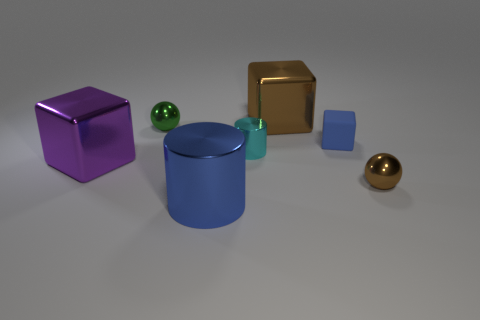There is a tiny green shiny ball; what number of small blue matte blocks are behind it?
Keep it short and to the point. 0. Is the number of green spheres greater than the number of big red rubber cylinders?
Provide a succinct answer. Yes. There is a metal cylinder that is the same color as the small block; what is its size?
Your response must be concise. Large. There is a shiny object that is behind the big purple metal object and on the right side of the cyan shiny object; what size is it?
Ensure brevity in your answer.  Large. What is the material of the block right of the big brown shiny block behind the blue object right of the large brown block?
Provide a short and direct response. Rubber. There is a thing that is the same color as the large cylinder; what material is it?
Make the answer very short. Rubber. There is a shiny cube in front of the green shiny ball; does it have the same color as the big metal cube behind the large purple object?
Offer a terse response. No. There is a brown thing that is in front of the tiny metal sphere that is on the left side of the sphere that is on the right side of the small green thing; what shape is it?
Make the answer very short. Sphere. There is a metallic thing that is both in front of the green object and on the left side of the big blue metallic thing; what shape is it?
Make the answer very short. Cube. What number of brown blocks are in front of the metal cube to the left of the small sphere that is on the left side of the big shiny cylinder?
Your answer should be very brief. 0. 